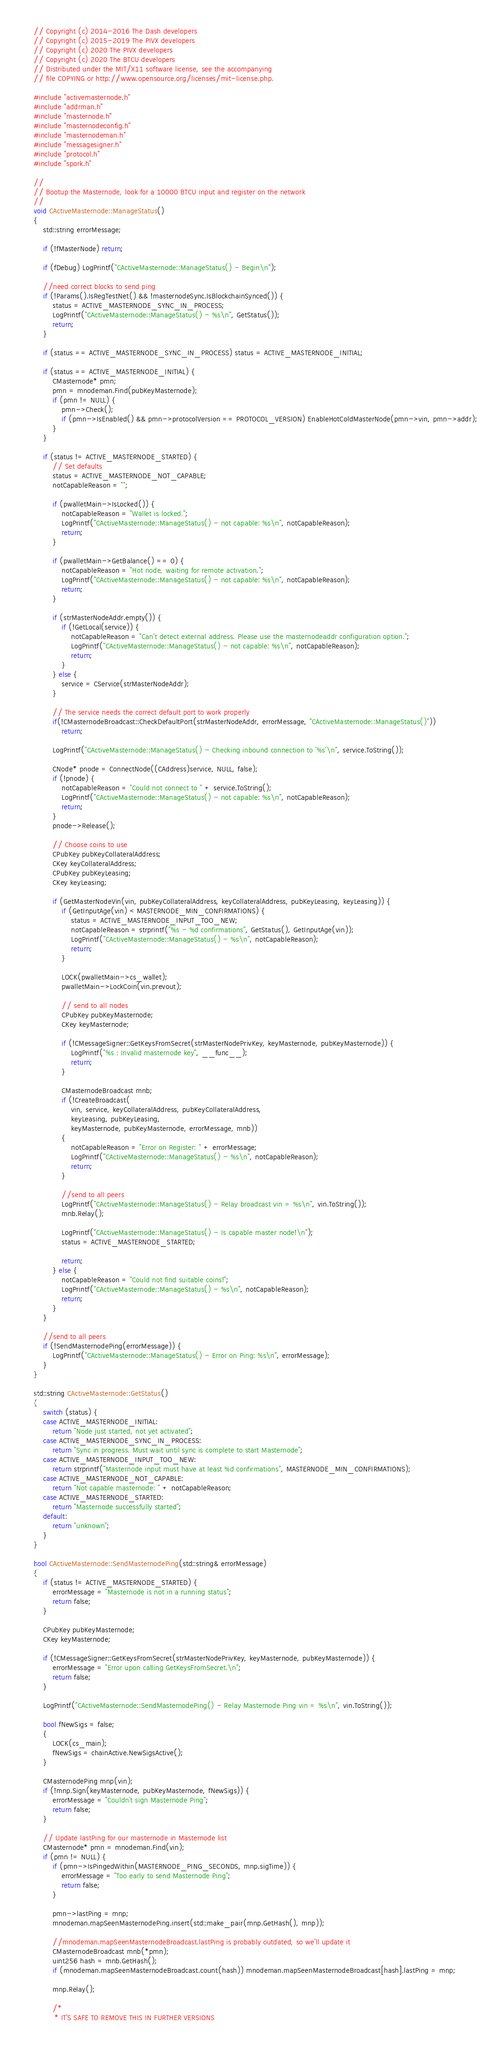<code> <loc_0><loc_0><loc_500><loc_500><_C++_>// Copyright (c) 2014-2016 The Dash developers
// Copyright (c) 2015-2019 The PIVX developers
// Copyright (c) 2020 The PIVX developers
// Copyright (c) 2020 The BTCU developers
// Distributed under the MIT/X11 software license, see the accompanying
// file COPYING or http://www.opensource.org/licenses/mit-license.php.

#include "activemasternode.h"
#include "addrman.h"
#include "masternode.h"
#include "masternodeconfig.h"
#include "masternodeman.h"
#include "messagesigner.h"
#include "protocol.h"
#include "spork.h"

//
// Bootup the Masternode, look for a 10000 BTCU input and register on the network
//
void CActiveMasternode::ManageStatus()
{
    std::string errorMessage;

    if (!fMasterNode) return;

    if (fDebug) LogPrintf("CActiveMasternode::ManageStatus() - Begin\n");

    //need correct blocks to send ping
    if (!Params().IsRegTestNet() && !masternodeSync.IsBlockchainSynced()) {
        status = ACTIVE_MASTERNODE_SYNC_IN_PROCESS;
        LogPrintf("CActiveMasternode::ManageStatus() - %s\n", GetStatus());
        return;
    }

    if (status == ACTIVE_MASTERNODE_SYNC_IN_PROCESS) status = ACTIVE_MASTERNODE_INITIAL;

    if (status == ACTIVE_MASTERNODE_INITIAL) {
        CMasternode* pmn;
        pmn = mnodeman.Find(pubKeyMasternode);
        if (pmn != NULL) {
            pmn->Check();
            if (pmn->IsEnabled() && pmn->protocolVersion == PROTOCOL_VERSION) EnableHotColdMasterNode(pmn->vin, pmn->addr);
        }
    }

    if (status != ACTIVE_MASTERNODE_STARTED) {
        // Set defaults
        status = ACTIVE_MASTERNODE_NOT_CAPABLE;
        notCapableReason = "";

        if (pwalletMain->IsLocked()) {
            notCapableReason = "Wallet is locked.";
            LogPrintf("CActiveMasternode::ManageStatus() - not capable: %s\n", notCapableReason);
            return;
        }

        if (pwalletMain->GetBalance() == 0) {
            notCapableReason = "Hot node, waiting for remote activation.";
            LogPrintf("CActiveMasternode::ManageStatus() - not capable: %s\n", notCapableReason);
            return;
        }

        if (strMasterNodeAddr.empty()) {
            if (!GetLocal(service)) {
                notCapableReason = "Can't detect external address. Please use the masternodeaddr configuration option.";
                LogPrintf("CActiveMasternode::ManageStatus() - not capable: %s\n", notCapableReason);
                return;
            }
        } else {
            service = CService(strMasterNodeAddr);
        }

        // The service needs the correct default port to work properly
        if(!CMasternodeBroadcast::CheckDefaultPort(strMasterNodeAddr, errorMessage, "CActiveMasternode::ManageStatus()"))
            return;

        LogPrintf("CActiveMasternode::ManageStatus() - Checking inbound connection to '%s'\n", service.ToString());

        CNode* pnode = ConnectNode((CAddress)service, NULL, false);
        if (!pnode) {
            notCapableReason = "Could not connect to " + service.ToString();
            LogPrintf("CActiveMasternode::ManageStatus() - not capable: %s\n", notCapableReason);
            return;
        }
        pnode->Release();

        // Choose coins to use
        CPubKey pubKeyCollateralAddress;
        CKey keyCollateralAddress;
        CPubKey pubKeyLeasing;
        CKey keyLeasing;

        if (GetMasterNodeVin(vin, pubKeyCollateralAddress, keyCollateralAddress, pubKeyLeasing, keyLeasing)) {
            if (GetInputAge(vin) < MASTERNODE_MIN_CONFIRMATIONS) {
                status = ACTIVE_MASTERNODE_INPUT_TOO_NEW;
                notCapableReason = strprintf("%s - %d confirmations", GetStatus(), GetInputAge(vin));
                LogPrintf("CActiveMasternode::ManageStatus() - %s\n", notCapableReason);
                return;
            }

            LOCK(pwalletMain->cs_wallet);
            pwalletMain->LockCoin(vin.prevout);

            // send to all nodes
            CPubKey pubKeyMasternode;
            CKey keyMasternode;

            if (!CMessageSigner::GetKeysFromSecret(strMasterNodePrivKey, keyMasternode, pubKeyMasternode)) {
                LogPrintf("%s : Invalid masternode key", __func__);
                return;
            }

            CMasternodeBroadcast mnb;
            if (!CreateBroadcast(
                vin, service, keyCollateralAddress, pubKeyCollateralAddress,
                keyLeasing, pubKeyLeasing,
                keyMasternode, pubKeyMasternode, errorMessage, mnb))
            {
                notCapableReason = "Error on Register: " + errorMessage;
                LogPrintf("CActiveMasternode::ManageStatus() - %s\n", notCapableReason);
                return;
            }

            //send to all peers
            LogPrintf("CActiveMasternode::ManageStatus() - Relay broadcast vin = %s\n", vin.ToString());
            mnb.Relay();

            LogPrintf("CActiveMasternode::ManageStatus() - Is capable master node!\n");
            status = ACTIVE_MASTERNODE_STARTED;

            return;
        } else {
            notCapableReason = "Could not find suitable coins!";
            LogPrintf("CActiveMasternode::ManageStatus() - %s\n", notCapableReason);
            return;
        }
    }

    //send to all peers
    if (!SendMasternodePing(errorMessage)) {
        LogPrintf("CActiveMasternode::ManageStatus() - Error on Ping: %s\n", errorMessage);
    }
}

std::string CActiveMasternode::GetStatus()
{
    switch (status) {
    case ACTIVE_MASTERNODE_INITIAL:
        return "Node just started, not yet activated";
    case ACTIVE_MASTERNODE_SYNC_IN_PROCESS:
        return "Sync in progress. Must wait until sync is complete to start Masternode";
    case ACTIVE_MASTERNODE_INPUT_TOO_NEW:
        return strprintf("Masternode input must have at least %d confirmations", MASTERNODE_MIN_CONFIRMATIONS);
    case ACTIVE_MASTERNODE_NOT_CAPABLE:
        return "Not capable masternode: " + notCapableReason;
    case ACTIVE_MASTERNODE_STARTED:
        return "Masternode successfully started";
    default:
        return "unknown";
    }
}

bool CActiveMasternode::SendMasternodePing(std::string& errorMessage)
{
    if (status != ACTIVE_MASTERNODE_STARTED) {
        errorMessage = "Masternode is not in a running status";
        return false;
    }

    CPubKey pubKeyMasternode;
    CKey keyMasternode;

    if (!CMessageSigner::GetKeysFromSecret(strMasterNodePrivKey, keyMasternode, pubKeyMasternode)) {
        errorMessage = "Error upon calling GetKeysFromSecret.\n";
        return false;
    }

    LogPrintf("CActiveMasternode::SendMasternodePing() - Relay Masternode Ping vin = %s\n", vin.ToString());

    bool fNewSigs = false;
    {
        LOCK(cs_main);
        fNewSigs = chainActive.NewSigsActive();
    }

    CMasternodePing mnp(vin);
    if (!mnp.Sign(keyMasternode, pubKeyMasternode, fNewSigs)) {
        errorMessage = "Couldn't sign Masternode Ping";
        return false;
    }

    // Update lastPing for our masternode in Masternode list
    CMasternode* pmn = mnodeman.Find(vin);
    if (pmn != NULL) {
        if (pmn->IsPingedWithin(MASTERNODE_PING_SECONDS, mnp.sigTime)) {
            errorMessage = "Too early to send Masternode Ping";
            return false;
        }

        pmn->lastPing = mnp;
        mnodeman.mapSeenMasternodePing.insert(std::make_pair(mnp.GetHash(), mnp));

        //mnodeman.mapSeenMasternodeBroadcast.lastPing is probably outdated, so we'll update it
        CMasternodeBroadcast mnb(*pmn);
        uint256 hash = mnb.GetHash();
        if (mnodeman.mapSeenMasternodeBroadcast.count(hash)) mnodeman.mapSeenMasternodeBroadcast[hash].lastPing = mnp;

        mnp.Relay();

        /*
         * IT'S SAFE TO REMOVE THIS IN FURTHER VERSIONS</code> 